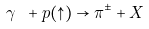<formula> <loc_0><loc_0><loc_500><loc_500>\gamma \ + p ( \uparrow ) \rightarrow \pi ^ { \pm } + X</formula> 